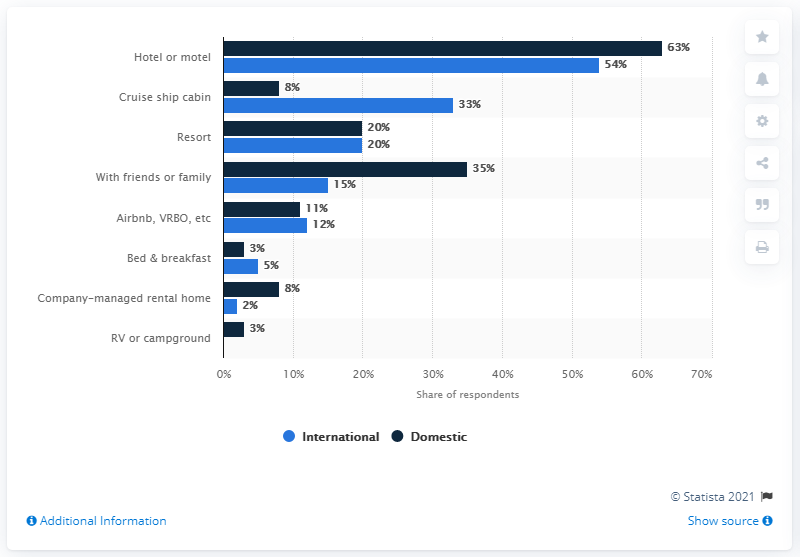Identify some key points in this picture. The light blue bar indicates international... On average, the average of two bars in a hotel or motel is 58.5. 